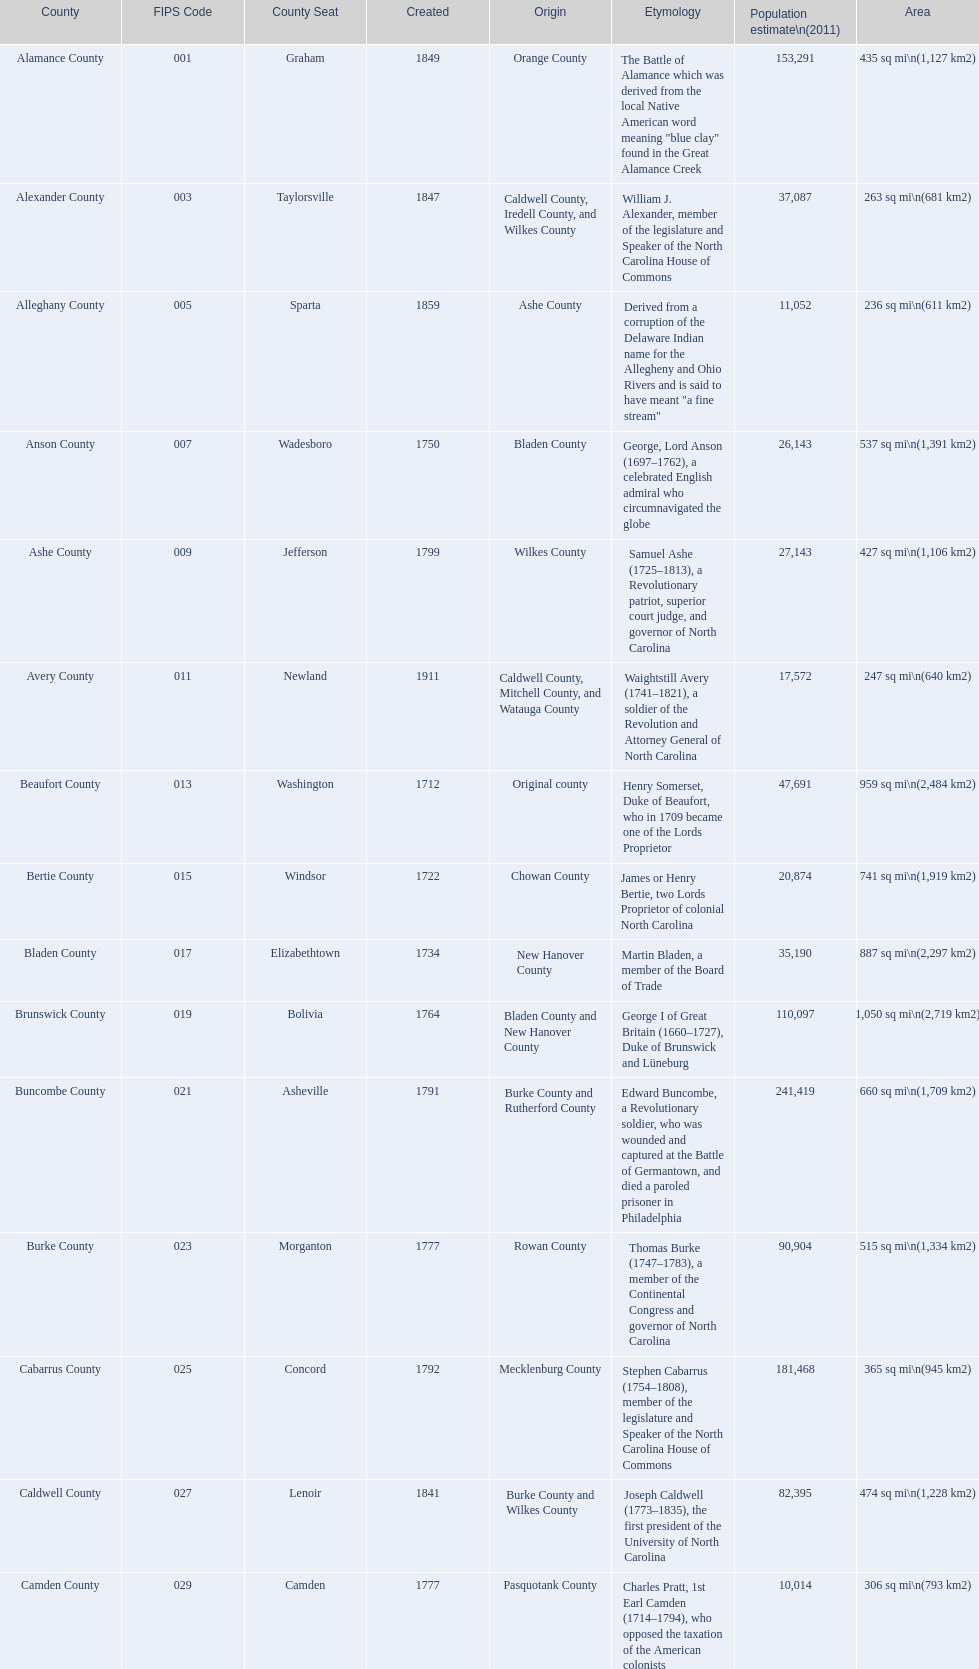Which county covers the most area? Dare County. 